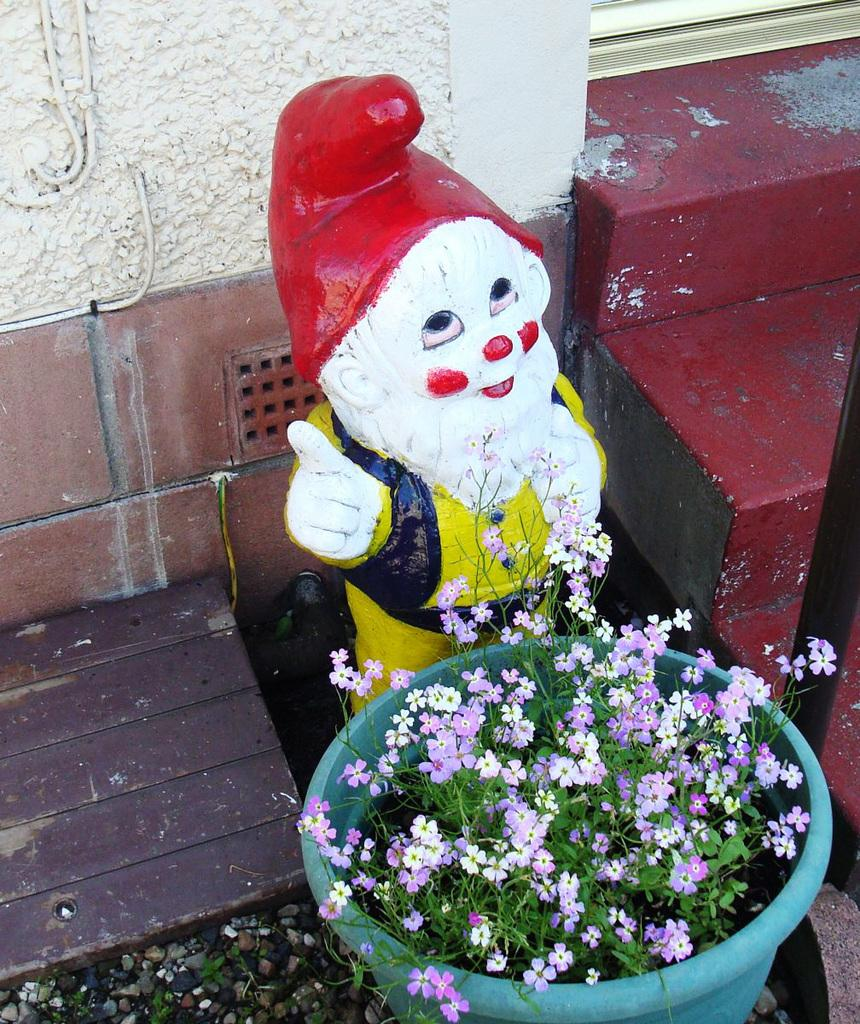What type of plant is in the flowerpot in the image? There is a plant with flowers in a flowerpot in the image. What can be seen in the sky in the image? Stars are visible in the image. What type of object is in the image that is typically used for play? There is a toy in the image. What is in the background of the image? There is a wall in the background of the image. What arithmetic problem is being solved on the wall in the image? There is no arithmetic problem visible on the wall in the image. What type of material is the plant's leaves made of in the image? The plant's leaves are made of plant material, not leather. 